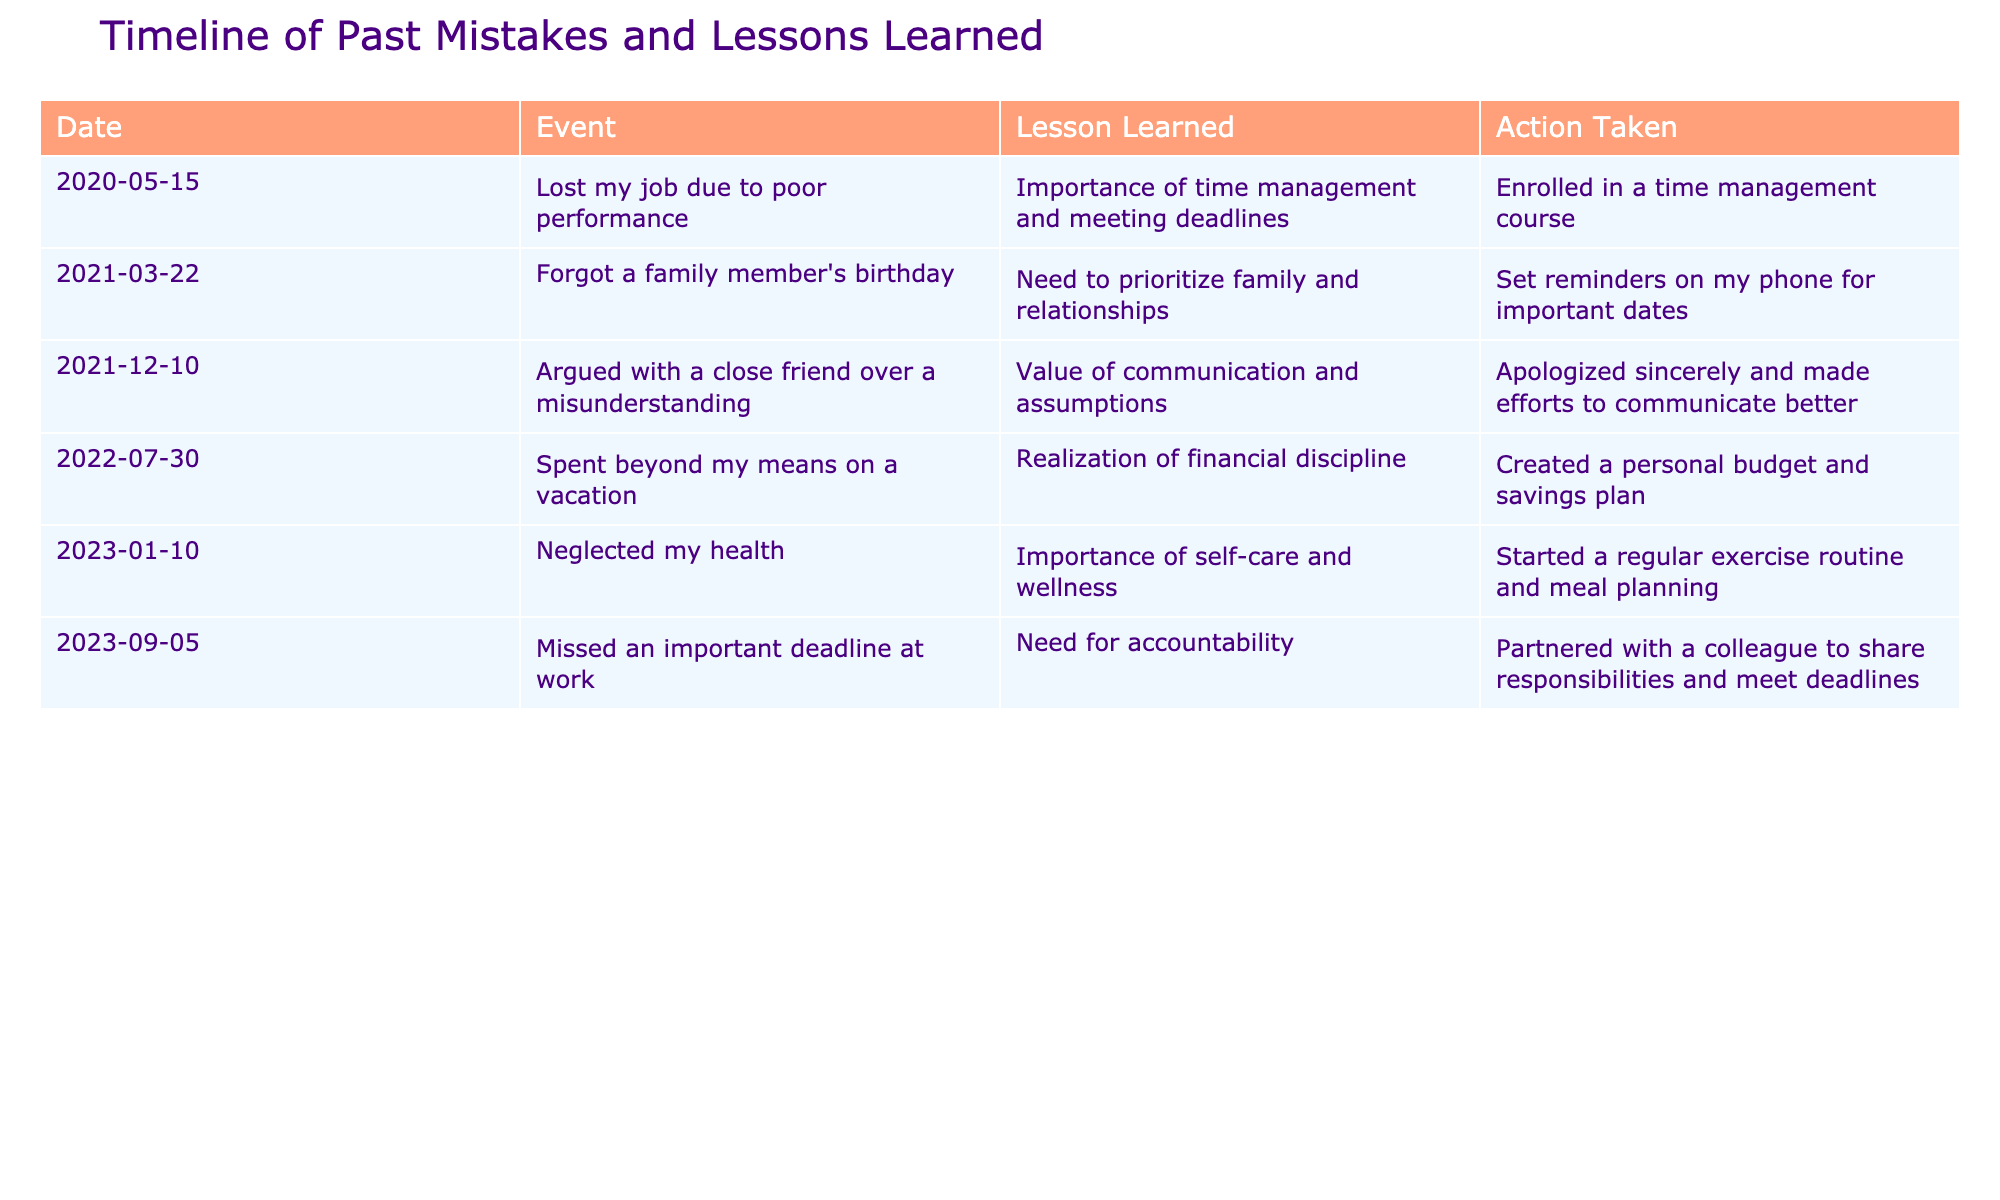What event occurred on March 22, 2021? Referring to the table, we find that the event listed under the date March 22, 2021, is "Forgot a family member's birthday."
Answer: Forgot a family member's birthday What lesson was learned from the job loss on May 15, 2020? Looking at the entry for May 15, 2020, the lesson learned was about the "Importance of time management and meeting deadlines."
Answer: Importance of time management and meeting deadlines How many events mentioned a need for accountability? In the table, only the entry for "Missed an important deadline at work" on September 5, 2023, specifically mentions the need for accountability. Therefore, there is one event.
Answer: 1 Was there an event related to financial discipline? Reviewing the table, the event from July 30, 2022, discusses spending beyond means and the realization of financial discipline. Hence, the answer is yes.
Answer: Yes What is the average timeframe between the events listed in the table? There are six events with dates provided. The first event is from May 15, 2020, and the last one is from September 5, 2023. The total span of time is approximately 3 years and 3 months for six events, which results in an average of about 6.5 months between each event (39 months / 6 events).
Answer: 6.5 months What actions were taken to prioritize family and relationships? From the entry on March 22, 2021, it specifies that the action taken was to "Set reminders on my phone for important dates" to prioritize family and relationships.
Answer: Set reminders on my phone for important dates How many lessons learned relate to personal health? In the table, the only entry relating to personal health is from January 10, 2023, which discusses the importance of self-care and wellness. Therefore, there is one lesson learned concerning personal health.
Answer: 1 Which event emphasizes the value of communication? According to the table, the event that emphasizes the value of communication occurred on December 10, 2021, which details an argument with a close friend over a misunderstanding.
Answer: Argued with a close friend over a misunderstanding What specific actions were taken after spending beyond means? The table indicates that, after spending beyond means on a vacation, the action taken was to "Create a personal budget and savings plan."
Answer: Create a personal budget and savings plan 